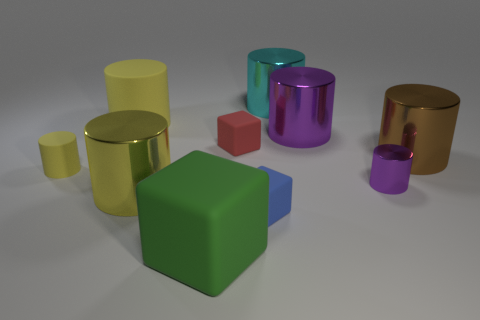What is the big yellow thing that is behind the small rubber object to the left of the large cube made of?
Ensure brevity in your answer.  Rubber. Is the number of large purple things on the right side of the yellow shiny cylinder the same as the number of cyan cylinders that are to the left of the blue cube?
Ensure brevity in your answer.  No. What number of objects are objects that are in front of the large cyan cylinder or metal cylinders on the left side of the large cyan metallic cylinder?
Ensure brevity in your answer.  9. There is a big cylinder that is in front of the small red block and left of the green thing; what is its material?
Your response must be concise. Metal. There is a red cube behind the tiny cylinder that is to the right of the matte object in front of the blue block; what size is it?
Provide a succinct answer. Small. Are there more big green things than large brown shiny balls?
Your response must be concise. Yes. Is the material of the small cylinder on the right side of the big yellow metal cylinder the same as the tiny blue object?
Offer a terse response. No. Is the number of purple objects less than the number of large brown things?
Offer a very short reply. No. Are there any large cylinders to the right of the shiny object that is behind the purple cylinder behind the tiny shiny thing?
Give a very brief answer. Yes. There is a big rubber thing in front of the blue thing; is its shape the same as the red matte thing?
Make the answer very short. Yes. 